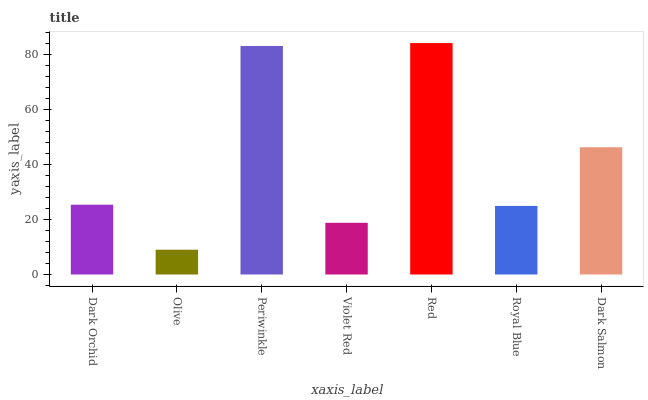Is Olive the minimum?
Answer yes or no. Yes. Is Red the maximum?
Answer yes or no. Yes. Is Periwinkle the minimum?
Answer yes or no. No. Is Periwinkle the maximum?
Answer yes or no. No. Is Periwinkle greater than Olive?
Answer yes or no. Yes. Is Olive less than Periwinkle?
Answer yes or no. Yes. Is Olive greater than Periwinkle?
Answer yes or no. No. Is Periwinkle less than Olive?
Answer yes or no. No. Is Dark Orchid the high median?
Answer yes or no. Yes. Is Dark Orchid the low median?
Answer yes or no. Yes. Is Olive the high median?
Answer yes or no. No. Is Red the low median?
Answer yes or no. No. 